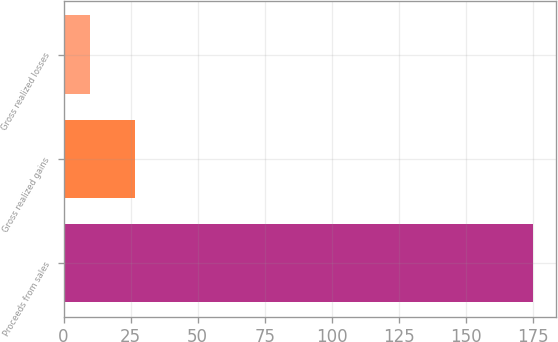Convert chart. <chart><loc_0><loc_0><loc_500><loc_500><bar_chart><fcel>Proceeds from sales<fcel>Gross realized gains<fcel>Gross realized losses<nl><fcel>175<fcel>26.5<fcel>10<nl></chart> 